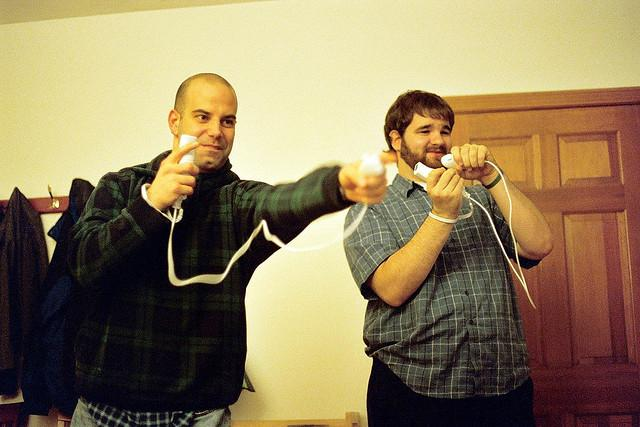What activity is the individual engaging in?

Choices:
A) boxing
B) climbing
C) running
D) taekwondo boxing 